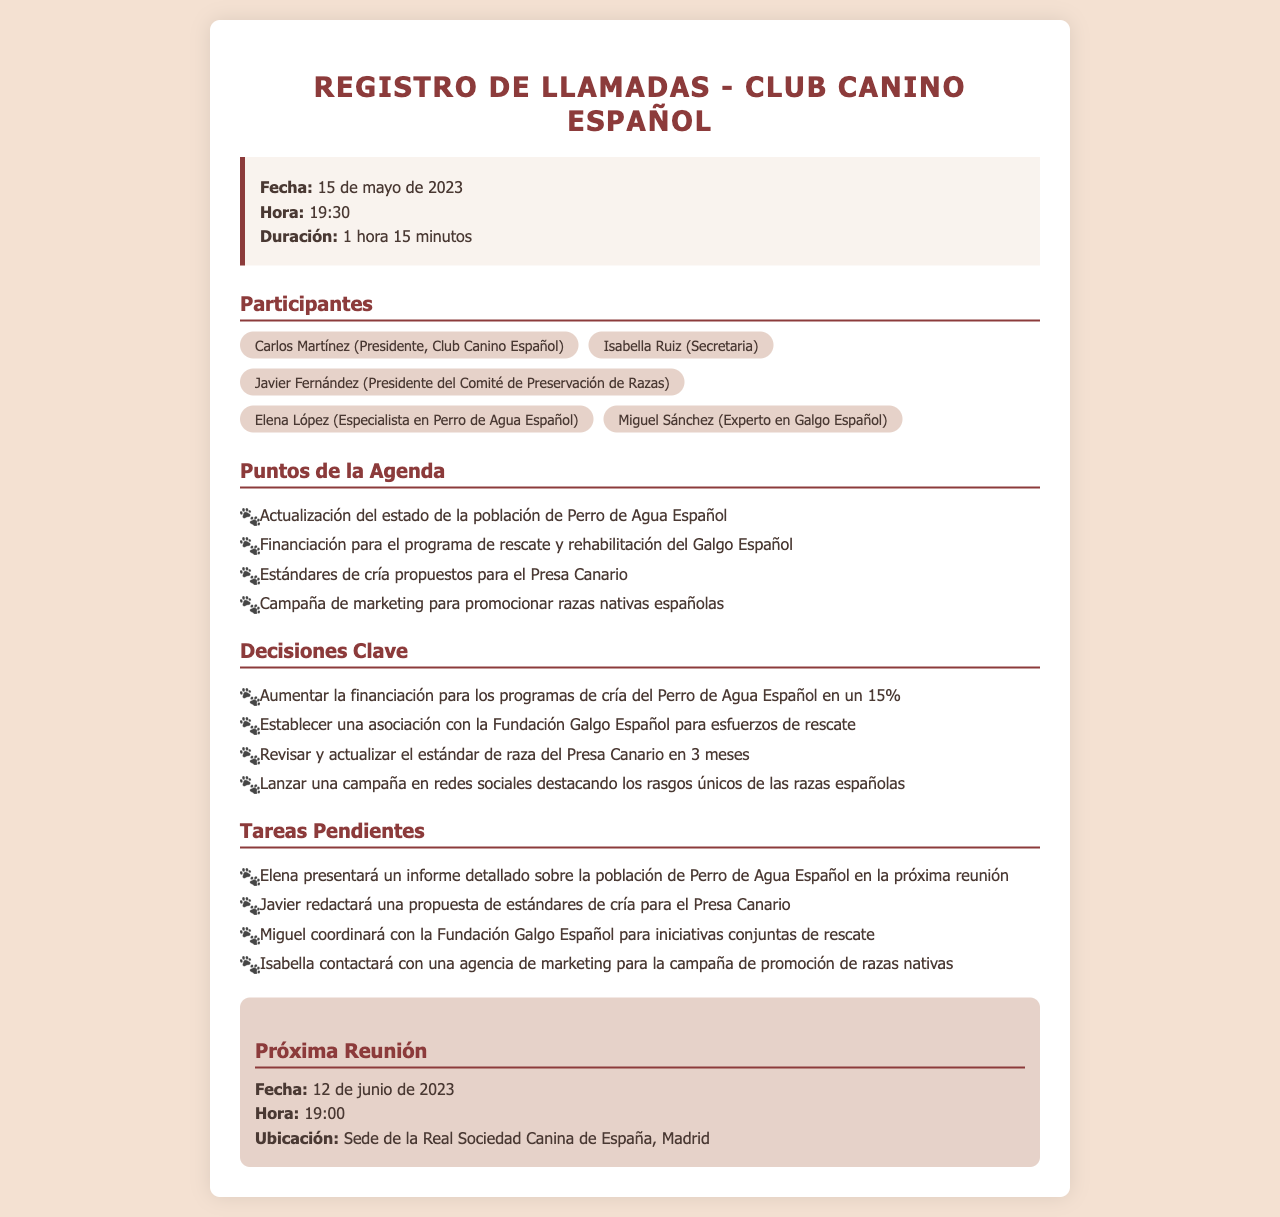¿Qué fecha tuvo la reunión? La fecha de la reunión se encuentra en el encabezado del registro de llamadas.
Answer: 15 de mayo de 2023 ¿Quién es el presidente del Club Canino Español? El nombre del presidente está listado entre los participantes de la reunión.
Answer: Carlos Martínez ¿Cuánto tiempo duró la llamada? La duración de la llamada se indica en la información del encabezado.
Answer: 1 hora 15 minutos ¿Cuál es el porcentaje de aumento de financiación para el Perro de Agua Español? El aumento de financiación se menciona en las decisiones clave de la reunión.
Answer: 15% ¿Qué una de las tareas pendientes de Miguel? Las tareas pendientes se enumeran en la sección correspondiente del documento.
Answer: Coordinar con la Fundación Galgo Español para iniciativas conjuntas de rescate ¿Cuándo es la próxima reunión programada? La fecha de la próxima reunión se encuentra en la sección de próxima reunión.
Answer: 12 de junio de 2023 ¿Cuál es el enfoque de la campaña de marketing? La campaña de marketing se menciona en los puntos de la agenda y decisiones.
Answer: Promocionar razas nativas españolas ¿Qué se revisará y actualizará en 3 meses? La revisión y actualización se especifican en las decisiones clave de la reunión.
Answer: Estándar de raza del Presa Canario 